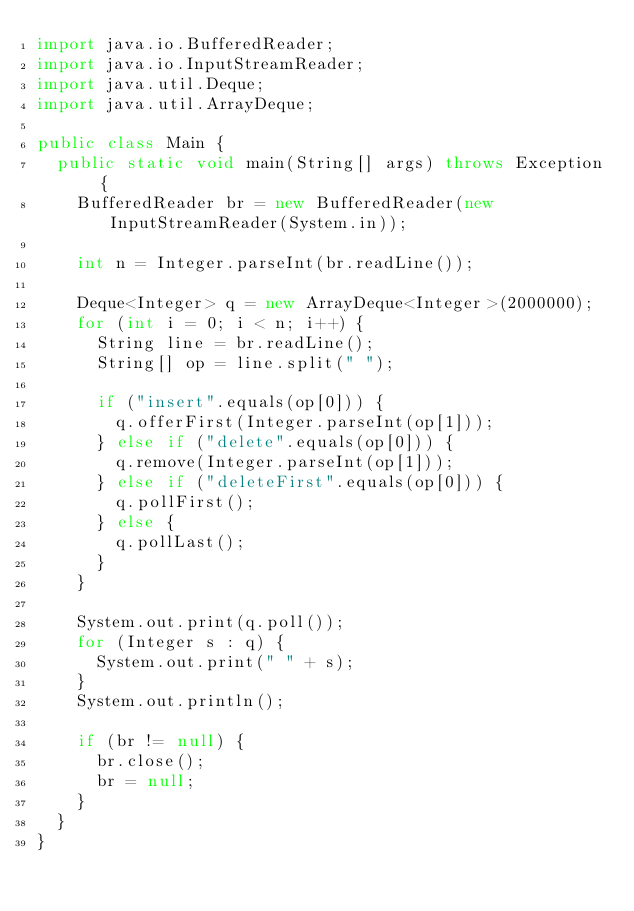Convert code to text. <code><loc_0><loc_0><loc_500><loc_500><_Java_>import java.io.BufferedReader;
import java.io.InputStreamReader;
import java.util.Deque;
import java.util.ArrayDeque;

public class Main {
	public static void main(String[] args) throws Exception {
		BufferedReader br = new BufferedReader(new InputStreamReader(System.in));

		int n = Integer.parseInt(br.readLine());

		Deque<Integer> q = new ArrayDeque<Integer>(2000000);
		for (int i = 0; i < n; i++) {
			String line = br.readLine();
			String[] op = line.split(" ");

			if ("insert".equals(op[0])) {
				q.offerFirst(Integer.parseInt(op[1]));
			} else if ("delete".equals(op[0])) {
				q.remove(Integer.parseInt(op[1]));
			} else if ("deleteFirst".equals(op[0])) {
				q.pollFirst();
			} else {
				q.pollLast();
			}
		}

		System.out.print(q.poll());
		for (Integer s : q) {
			System.out.print(" " + s);
		}
		System.out.println();

		if (br != null) {
			br.close();
			br = null;
		}
	}
}</code> 